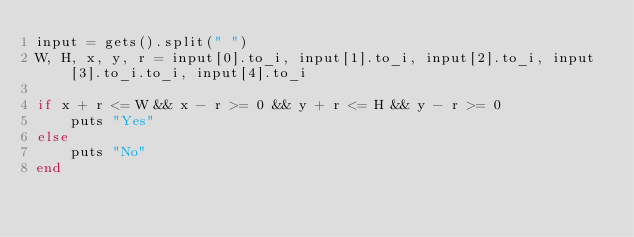<code> <loc_0><loc_0><loc_500><loc_500><_Ruby_>input = gets().split(" ")
W, H, x, y, r = input[0].to_i, input[1].to_i, input[2].to_i, input[3].to_i.to_i, input[4].to_i

if x + r <= W && x - r >= 0 && y + r <= H && y - r >= 0
	puts "Yes"
else
	puts "No"
end</code> 